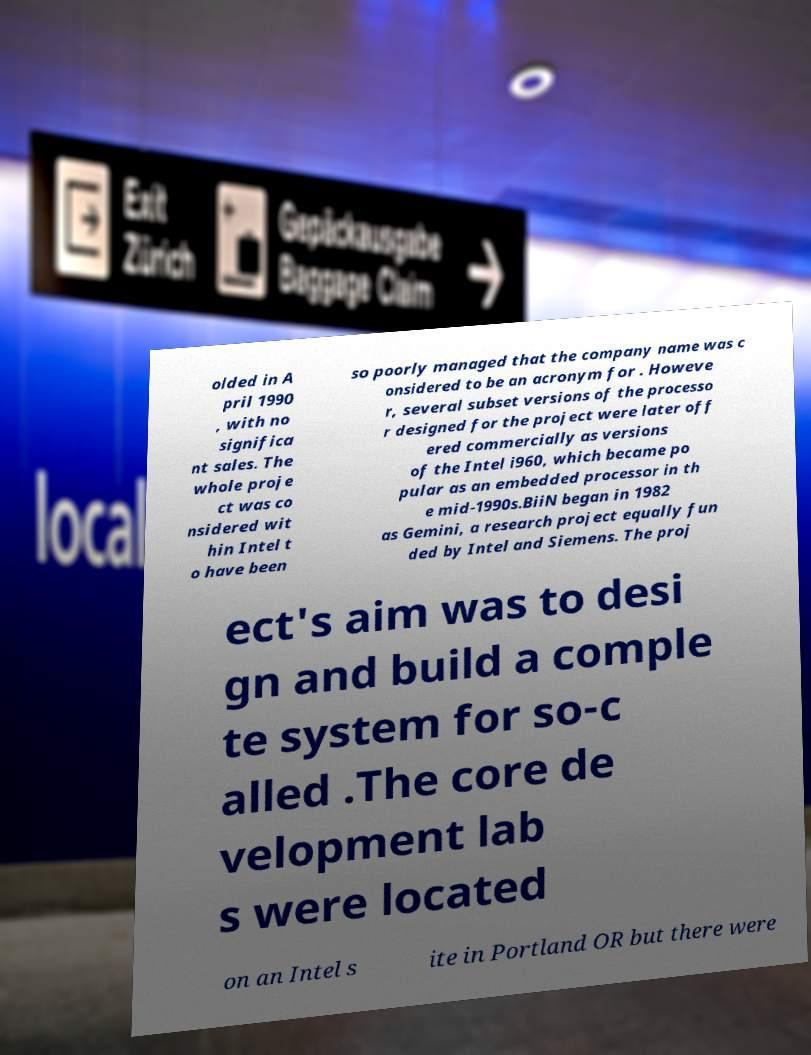Please read and relay the text visible in this image. What does it say? olded in A pril 1990 , with no significa nt sales. The whole proje ct was co nsidered wit hin Intel t o have been so poorly managed that the company name was c onsidered to be an acronym for . Howeve r, several subset versions of the processo r designed for the project were later off ered commercially as versions of the Intel i960, which became po pular as an embedded processor in th e mid-1990s.BiiN began in 1982 as Gemini, a research project equally fun ded by Intel and Siemens. The proj ect's aim was to desi gn and build a comple te system for so-c alled .The core de velopment lab s were located on an Intel s ite in Portland OR but there were 